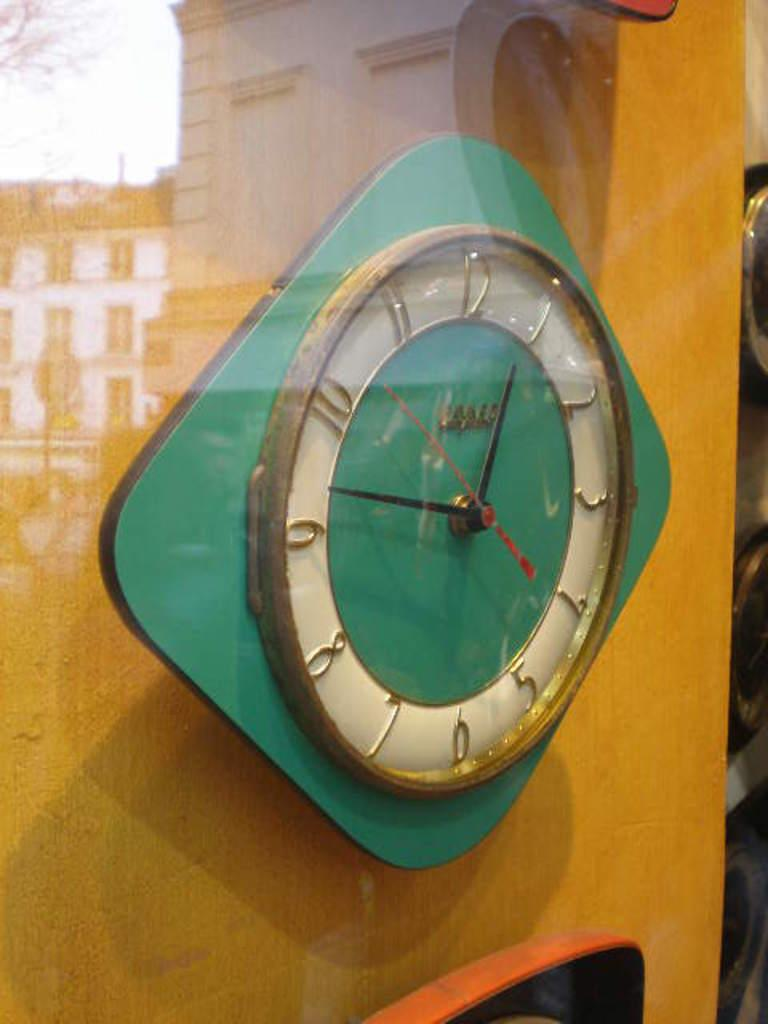<image>
Share a concise interpretation of the image provided. A vintage clock hangs inside a glass window, showing the time as 12:47. 